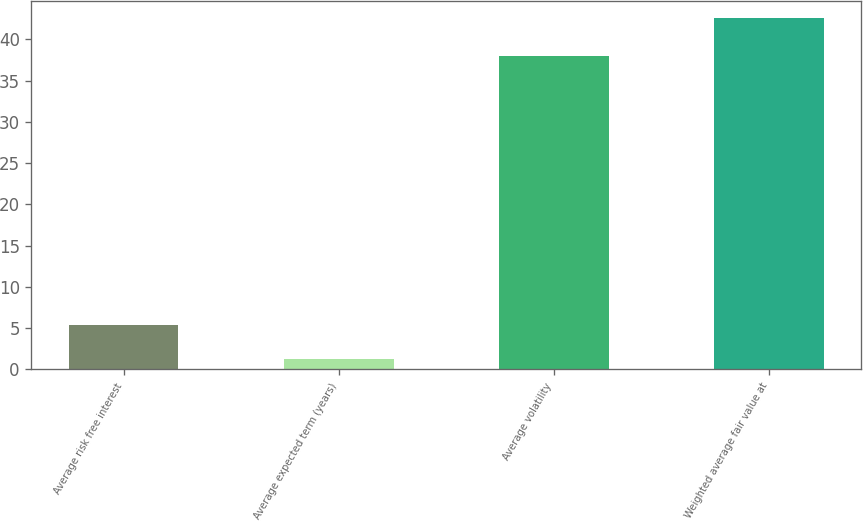Convert chart to OTSL. <chart><loc_0><loc_0><loc_500><loc_500><bar_chart><fcel>Average risk free interest<fcel>Average expected term (years)<fcel>Average volatility<fcel>Weighted average fair value at<nl><fcel>5.42<fcel>1.3<fcel>38<fcel>42.54<nl></chart> 